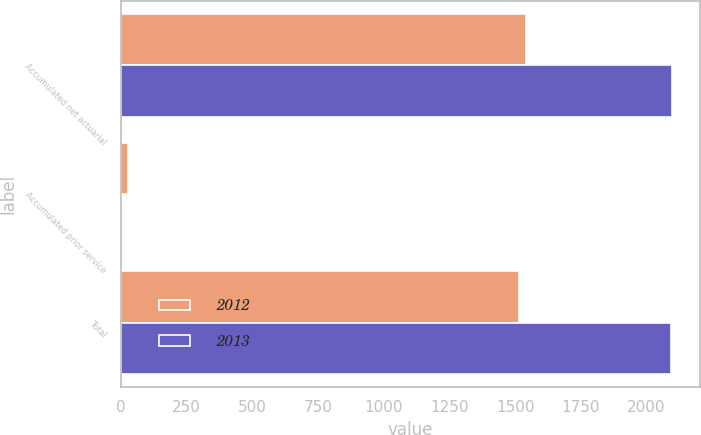<chart> <loc_0><loc_0><loc_500><loc_500><stacked_bar_chart><ecel><fcel>Accumulated net actuarial<fcel>Accumulated prior service<fcel>Total<nl><fcel>2012<fcel>1542<fcel>26<fcel>1516<nl><fcel>2013<fcel>2097<fcel>3<fcel>2094<nl></chart> 